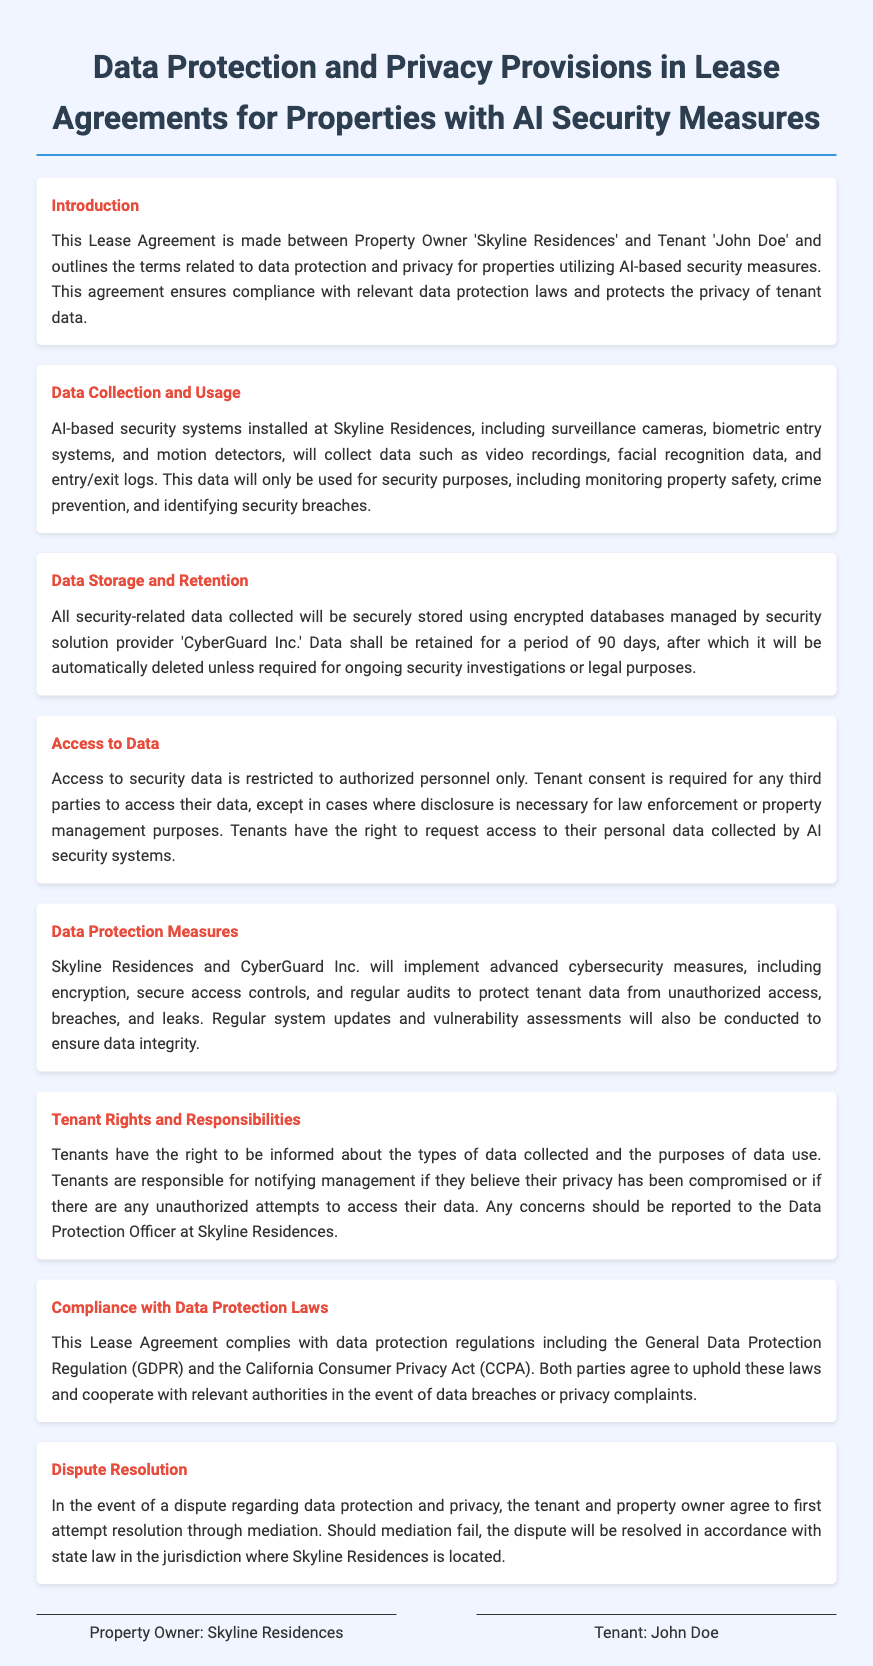What is the name of the property owner? The document states that the property owner is 'Skyline Residences'.
Answer: Skyline Residences Who is the tenant in the lease agreement? The tenant mentioned in the lease agreement is 'John Doe'.
Answer: John Doe What is the duration for which data is retained? According to the document, security-related data is retained for a period of 90 days.
Answer: 90 days What is required for third parties to access tenant data? The document specifies that tenant consent is required for any third parties to access their data.
Answer: Tenant consent Which company manages data storage? The text indicates that the security solution provider 'CyberGuard Inc.' manages the encrypted databases for data storage.
Answer: CyberGuard Inc What are tenants responsible for regarding their data? Tenants are responsible for notifying management if they believe their privacy has been compromised.
Answer: Notifying management Under which regulations does this lease agreement comply? The document states that the lease agreement complies with the General Data Protection Regulation (GDPR) and the California Consumer Privacy Act (CCPA).
Answer: GDPR and CCPA What is the first step in dispute resolution? The agreement mentions that the tenant and property owner should first attempt resolution through mediation.
Answer: Mediation 